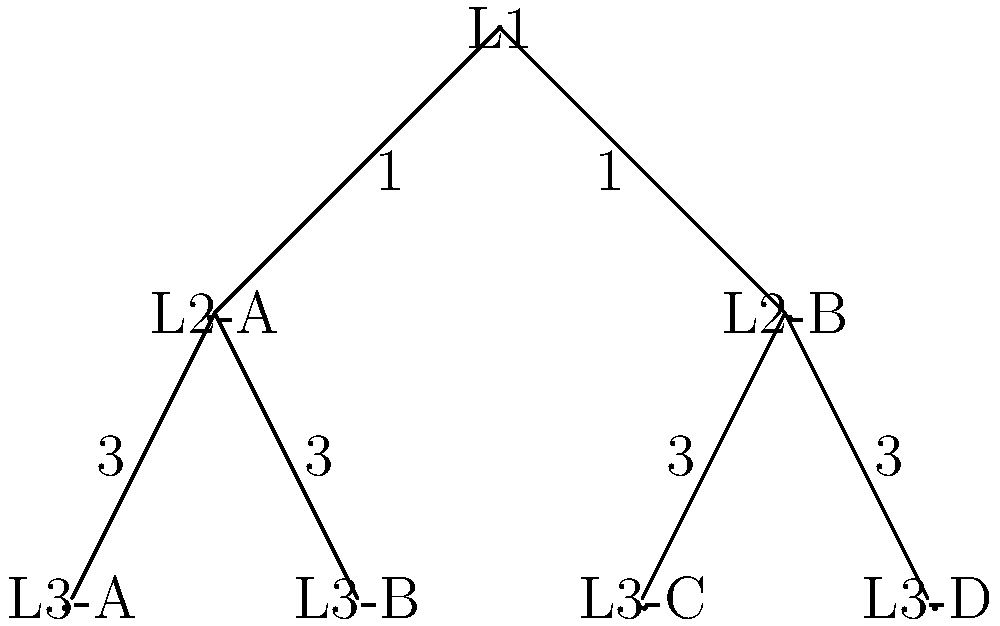In the given memory hierarchy diagram modeled as a tree, each node represents a cache level, and the edges represent the latency (in nanoseconds) between levels. What is the minimum latency path from L1 to any L3 cache, and what is its total latency? To find the minimum latency path from L1 to any L3 cache, we need to:

1. Identify all possible paths from L1 to L3 caches:
   - L1 -> L2-A -> L3-A
   - L1 -> L2-A -> L3-B
   - L1 -> L2-B -> L3-C
   - L1 -> L2-B -> L3-D

2. Calculate the total latency for each path:
   - L1 -> L2-A -> L3-A: $1 + 3 = 4$ ns
   - L1 -> L2-A -> L3-B: $1 + 3 = 4$ ns
   - L1 -> L2-B -> L3-C: $1 + 3 = 4$ ns
   - L1 -> L2-B -> L3-D: $1 + 3 = 4$ ns

3. Observe that all paths have the same total latency of 4 ns.

4. Choose any of these paths as they all have the minimum latency.

Therefore, the minimum latency path from L1 to any L3 cache is 4 ns, and it can be achieved through any of the four paths mentioned above.
Answer: 4 ns 